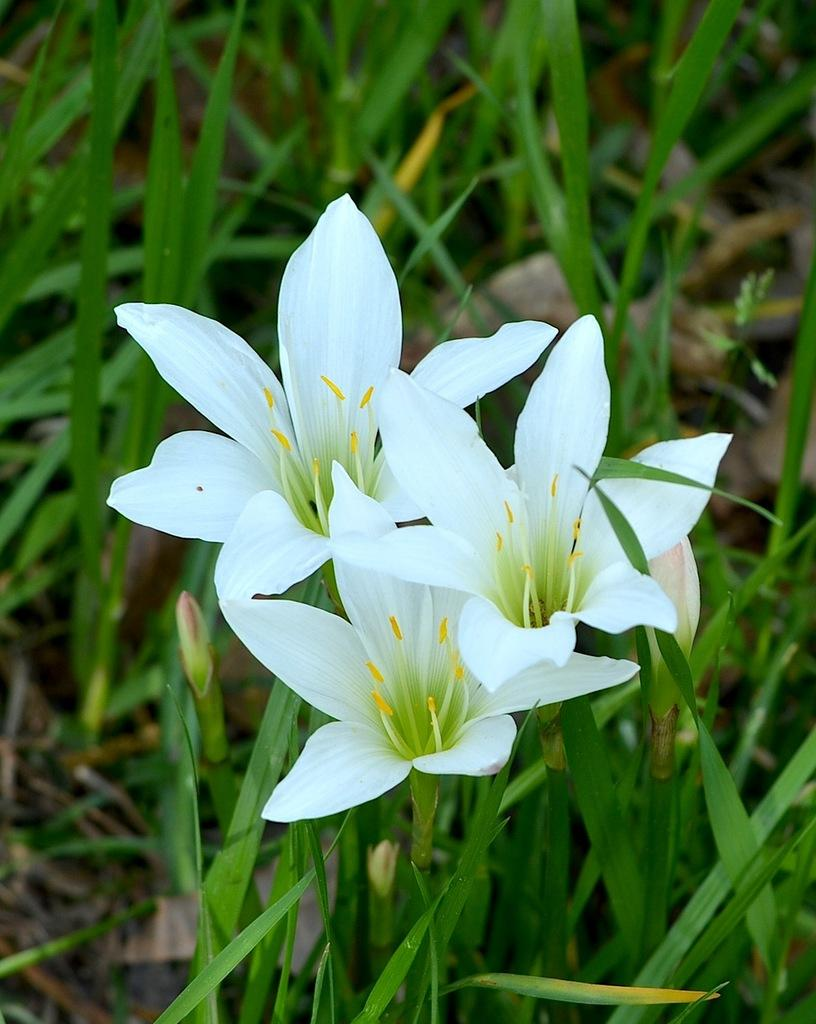How many flowers are visible in the image? There are three white color flowers in the image. What are the flowers placed on? The flowers are on plants. What else can be seen in the background of the image? There are other plants in the background of the image. How many lizards can be seen hiding among the flowers in the image? There are no lizards present in the image; it only features flowers and plants. Is the image of the flowers accompanied by a bulb in the image? There is no mention of a bulb in the image, only flowers and plants. 